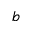<formula> <loc_0><loc_0><loc_500><loc_500>b</formula> 